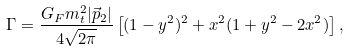<formula> <loc_0><loc_0><loc_500><loc_500>\Gamma = \frac { G _ { F } m _ { t } ^ { 2 } | \vec { p } _ { 2 } | } { 4 \sqrt { 2 \pi } } \left [ ( 1 - y ^ { 2 } ) ^ { 2 } + x ^ { 2 } ( 1 + y ^ { 2 } - 2 x ^ { 2 } ) \right ] ,</formula> 